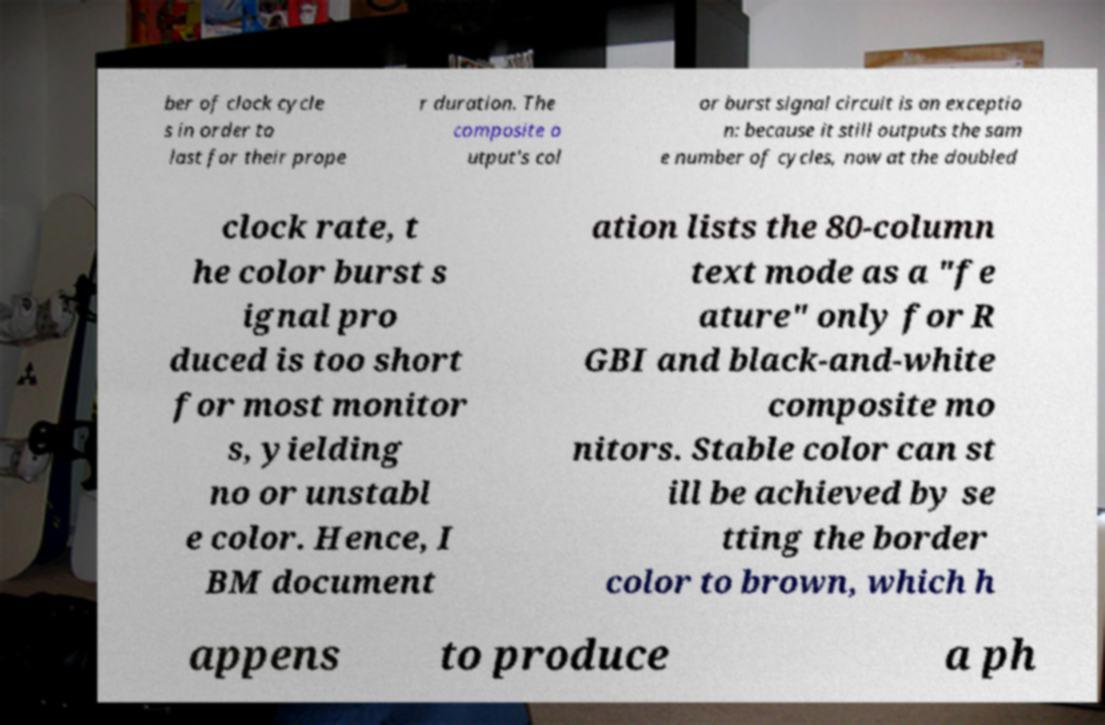Can you read and provide the text displayed in the image?This photo seems to have some interesting text. Can you extract and type it out for me? ber of clock cycle s in order to last for their prope r duration. The composite o utput's col or burst signal circuit is an exceptio n: because it still outputs the sam e number of cycles, now at the doubled clock rate, t he color burst s ignal pro duced is too short for most monitor s, yielding no or unstabl e color. Hence, I BM document ation lists the 80-column text mode as a "fe ature" only for R GBI and black-and-white composite mo nitors. Stable color can st ill be achieved by se tting the border color to brown, which h appens to produce a ph 